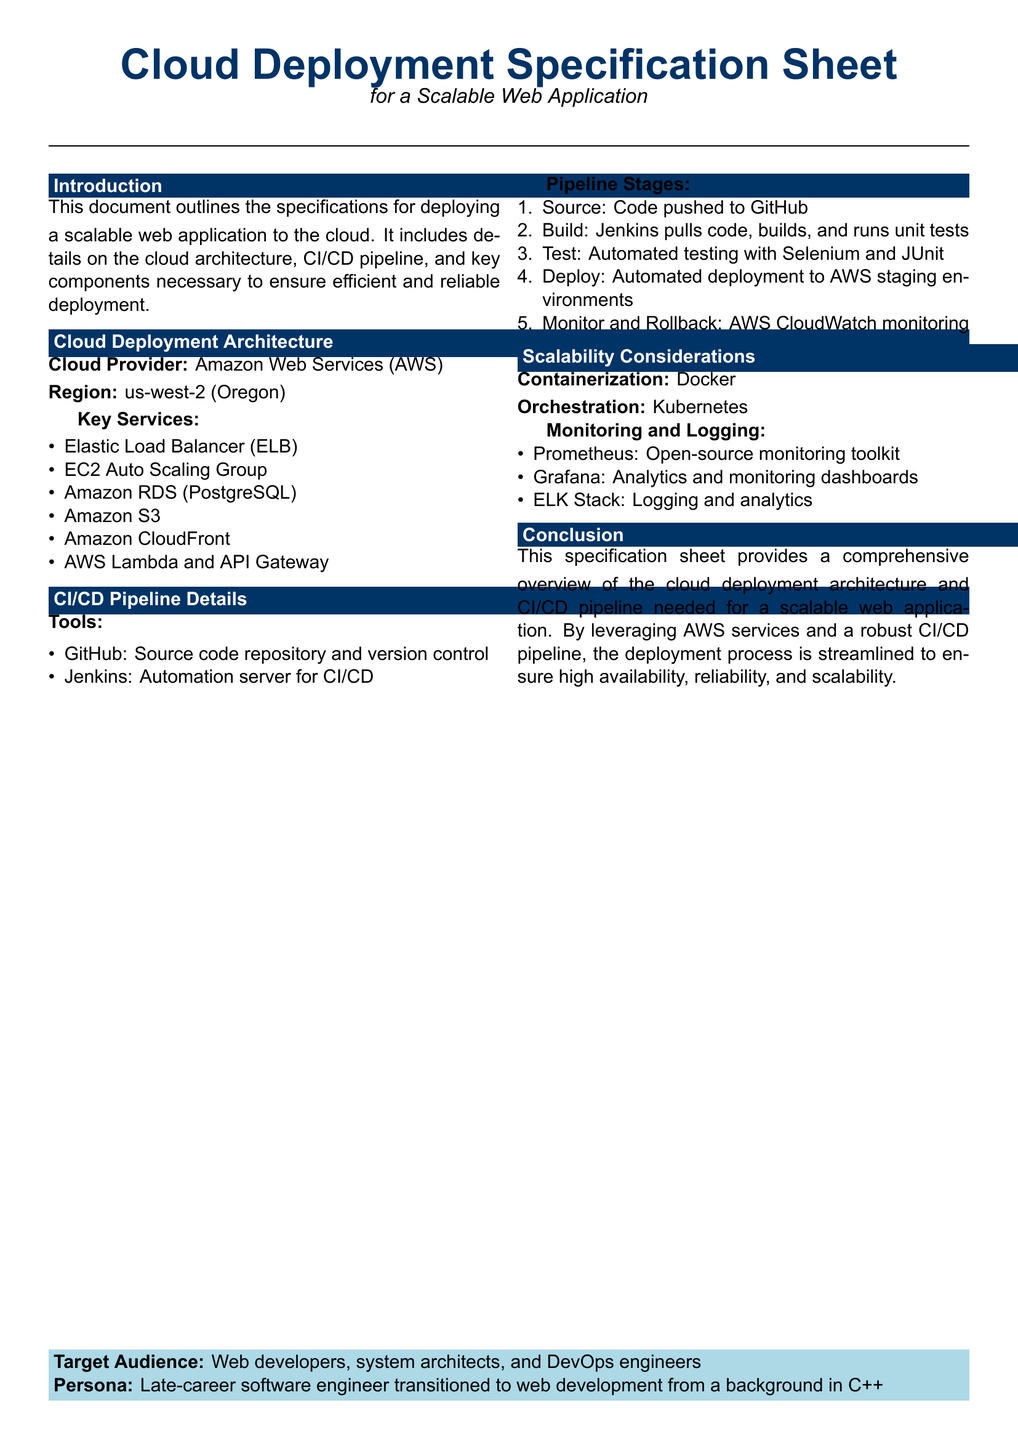what is the cloud provider? The document specifies that the cloud provider is Amazon Web Services.
Answer: Amazon Web Services what is the region specified for deployment? The document states that the deployment region is us-west-2.
Answer: us-west-2 which database service is mentioned? The specification lists Amazon RDS with PostgreSQL as the database service.
Answer: Amazon RDS (PostgreSQL) what is the automation server used for CI/CD? The document indicates that Jenkins is the automation server used for CI/CD.
Answer: Jenkins how many stages are there in the CI/CD pipeline? The document outlines five stages in the CI/CD pipeline.
Answer: 5 what monitoring tool is mentioned for logging? The specification references the ELK Stack as a logging and analytics tool.
Answer: ELK Stack which containerization technology is specified? The document mentions Docker as the containerization technology.
Answer: Docker who is the target audience for this document? The target audience includes web developers, system architects, and DevOps engineers.
Answer: Web developers, system architects, and DevOps engineers what orchestration tool is indicated? The document specifies Kubernetes as the orchestration tool.
Answer: Kubernetes what is the main purpose of this specification sheet? The document outlines specifications for deploying a scalable web application in the cloud.
Answer: Deploying a scalable web application in the cloud 